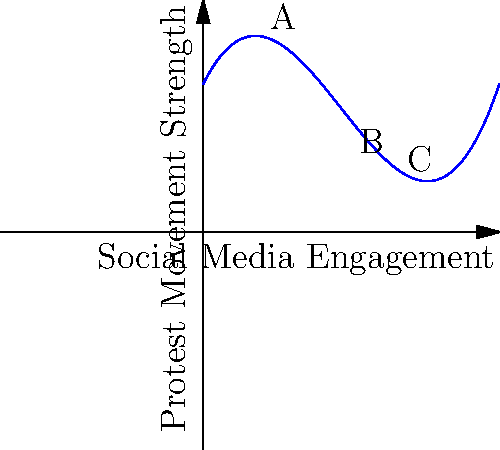The polynomial graph above represents the relationship between social media engagement and protest movement strength in a hypothetical scenario. Considering the current landscape of digital activism in Russia, analyze the graph and determine at which point (A, B, or C) the marginal impact of increased social media engagement on protest movement strength is highest. Explain your reasoning based on the graph's shape and the concept of rate of change. To determine the point with the highest marginal impact, we need to analyze the rate of change (slope) of the curve at each point:

1. Point A (early stage):
   - The curve is relatively steep, indicating a significant positive impact of social media engagement on protest movement strength.
   - However, the slope is not at its maximum here.

2. Point B (middle stage):
   - The curve reaches its steepest point around this area.
   - The tangent line at this point would have the greatest positive slope.
   - This indicates that small increases in social media engagement lead to the largest gains in protest movement strength.

3. Point C (later stage):
   - The curve's slope is decreasing and starting to level off.
   - While still positive, the marginal impact is less than at point B.

The highest marginal impact occurs where the curve's slope is greatest, which is at point B. This represents the "tipping point" where social media engagement is most effective at strengthening the protest movement.

In the context of digital activism in Russia, this point could represent a critical mass of online engagement where the movement gains significant momentum and visibility, potentially leading to greater offline participation and impact.
Answer: Point B 